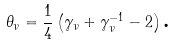<formula> <loc_0><loc_0><loc_500><loc_500>\theta _ { \nu } = \frac { 1 } { 4 } \left ( \gamma _ { \nu } + \gamma _ { \nu } ^ { - 1 } - 2 \right ) \text {.}</formula> 